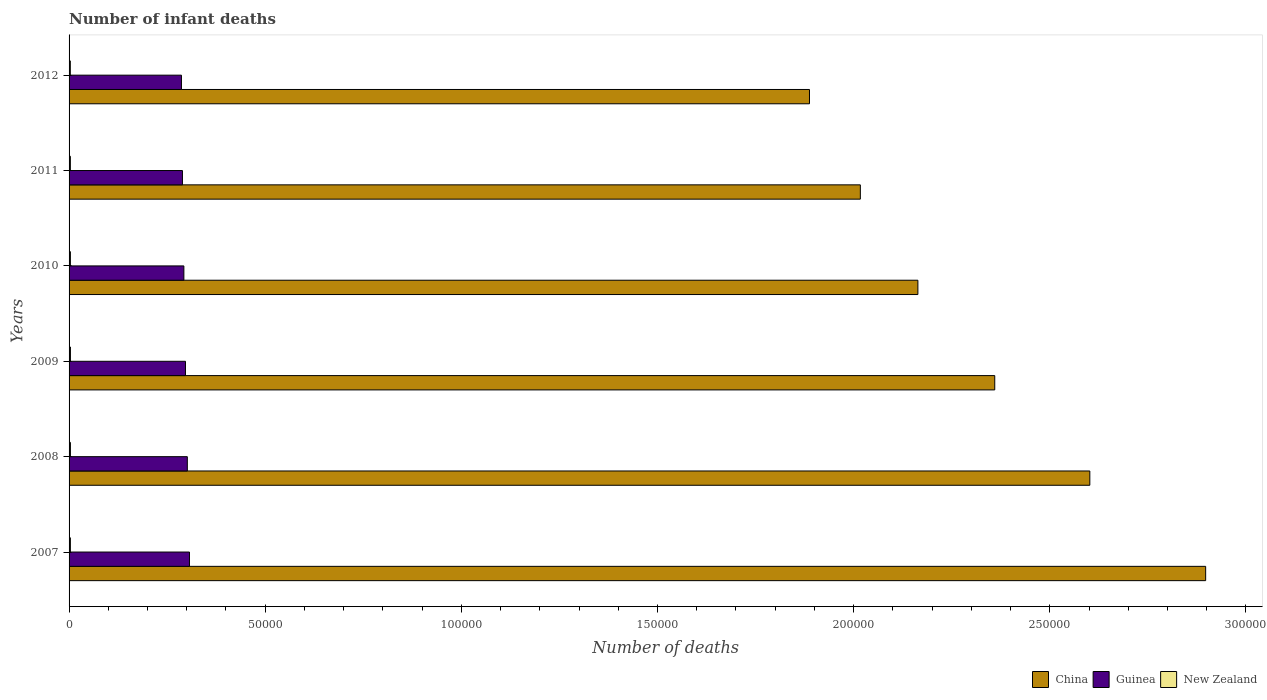How many different coloured bars are there?
Offer a very short reply. 3. Are the number of bars per tick equal to the number of legend labels?
Keep it short and to the point. Yes. How many bars are there on the 4th tick from the top?
Your response must be concise. 3. What is the number of infant deaths in Guinea in 2007?
Offer a terse response. 3.07e+04. Across all years, what is the maximum number of infant deaths in New Zealand?
Make the answer very short. 347. Across all years, what is the minimum number of infant deaths in China?
Make the answer very short. 1.89e+05. In which year was the number of infant deaths in New Zealand maximum?
Offer a very short reply. 2009. What is the total number of infant deaths in Guinea in the graph?
Give a very brief answer. 1.77e+05. What is the difference between the number of infant deaths in New Zealand in 2008 and that in 2009?
Make the answer very short. -1. What is the difference between the number of infant deaths in China in 2010 and the number of infant deaths in Guinea in 2011?
Your response must be concise. 1.87e+05. What is the average number of infant deaths in New Zealand per year?
Give a very brief answer. 337. In the year 2012, what is the difference between the number of infant deaths in China and number of infant deaths in New Zealand?
Keep it short and to the point. 1.88e+05. In how many years, is the number of infant deaths in New Zealand greater than 160000 ?
Make the answer very short. 0. What is the ratio of the number of infant deaths in Guinea in 2007 to that in 2012?
Provide a succinct answer. 1.07. Is the difference between the number of infant deaths in China in 2011 and 2012 greater than the difference between the number of infant deaths in New Zealand in 2011 and 2012?
Offer a very short reply. Yes. What is the difference between the highest and the second highest number of infant deaths in China?
Offer a terse response. 2.95e+04. What is the difference between the highest and the lowest number of infant deaths in New Zealand?
Provide a succinct answer. 28. In how many years, is the number of infant deaths in China greater than the average number of infant deaths in China taken over all years?
Provide a succinct answer. 3. Is the sum of the number of infant deaths in New Zealand in 2009 and 2011 greater than the maximum number of infant deaths in Guinea across all years?
Ensure brevity in your answer.  No. What does the 2nd bar from the top in 2008 represents?
Provide a succinct answer. Guinea. What does the 2nd bar from the bottom in 2010 represents?
Your response must be concise. Guinea. Is it the case that in every year, the sum of the number of infant deaths in Guinea and number of infant deaths in China is greater than the number of infant deaths in New Zealand?
Provide a succinct answer. Yes. Are all the bars in the graph horizontal?
Make the answer very short. Yes. Are the values on the major ticks of X-axis written in scientific E-notation?
Give a very brief answer. No. How many legend labels are there?
Your response must be concise. 3. What is the title of the graph?
Offer a terse response. Number of infant deaths. Does "Ukraine" appear as one of the legend labels in the graph?
Your response must be concise. No. What is the label or title of the X-axis?
Ensure brevity in your answer.  Number of deaths. What is the label or title of the Y-axis?
Offer a terse response. Years. What is the Number of deaths in China in 2007?
Your answer should be very brief. 2.90e+05. What is the Number of deaths in Guinea in 2007?
Your answer should be compact. 3.07e+04. What is the Number of deaths in New Zealand in 2007?
Your response must be concise. 335. What is the Number of deaths of China in 2008?
Your answer should be compact. 2.60e+05. What is the Number of deaths of Guinea in 2008?
Give a very brief answer. 3.01e+04. What is the Number of deaths of New Zealand in 2008?
Provide a short and direct response. 346. What is the Number of deaths in China in 2009?
Offer a terse response. 2.36e+05. What is the Number of deaths of Guinea in 2009?
Offer a very short reply. 2.97e+04. What is the Number of deaths of New Zealand in 2009?
Your response must be concise. 347. What is the Number of deaths of China in 2010?
Provide a succinct answer. 2.16e+05. What is the Number of deaths in Guinea in 2010?
Provide a succinct answer. 2.93e+04. What is the Number of deaths of New Zealand in 2010?
Provide a succinct answer. 342. What is the Number of deaths of China in 2011?
Make the answer very short. 2.02e+05. What is the Number of deaths of Guinea in 2011?
Provide a short and direct response. 2.89e+04. What is the Number of deaths of New Zealand in 2011?
Provide a short and direct response. 333. What is the Number of deaths in China in 2012?
Ensure brevity in your answer.  1.89e+05. What is the Number of deaths in Guinea in 2012?
Your answer should be compact. 2.86e+04. What is the Number of deaths of New Zealand in 2012?
Your answer should be very brief. 319. Across all years, what is the maximum Number of deaths of China?
Make the answer very short. 2.90e+05. Across all years, what is the maximum Number of deaths of Guinea?
Provide a succinct answer. 3.07e+04. Across all years, what is the maximum Number of deaths in New Zealand?
Offer a terse response. 347. Across all years, what is the minimum Number of deaths in China?
Offer a very short reply. 1.89e+05. Across all years, what is the minimum Number of deaths of Guinea?
Provide a succinct answer. 2.86e+04. Across all years, what is the minimum Number of deaths in New Zealand?
Make the answer very short. 319. What is the total Number of deaths of China in the graph?
Your response must be concise. 1.39e+06. What is the total Number of deaths in Guinea in the graph?
Make the answer very short. 1.77e+05. What is the total Number of deaths of New Zealand in the graph?
Keep it short and to the point. 2022. What is the difference between the Number of deaths of China in 2007 and that in 2008?
Give a very brief answer. 2.95e+04. What is the difference between the Number of deaths in Guinea in 2007 and that in 2008?
Your response must be concise. 553. What is the difference between the Number of deaths of New Zealand in 2007 and that in 2008?
Your answer should be very brief. -11. What is the difference between the Number of deaths in China in 2007 and that in 2009?
Your answer should be compact. 5.38e+04. What is the difference between the Number of deaths in Guinea in 2007 and that in 2009?
Ensure brevity in your answer.  1023. What is the difference between the Number of deaths in New Zealand in 2007 and that in 2009?
Offer a terse response. -12. What is the difference between the Number of deaths of China in 2007 and that in 2010?
Give a very brief answer. 7.34e+04. What is the difference between the Number of deaths of Guinea in 2007 and that in 2010?
Your answer should be very brief. 1432. What is the difference between the Number of deaths in China in 2007 and that in 2011?
Offer a terse response. 8.80e+04. What is the difference between the Number of deaths of Guinea in 2007 and that in 2011?
Offer a terse response. 1796. What is the difference between the Number of deaths in New Zealand in 2007 and that in 2011?
Keep it short and to the point. 2. What is the difference between the Number of deaths in China in 2007 and that in 2012?
Offer a very short reply. 1.01e+05. What is the difference between the Number of deaths of Guinea in 2007 and that in 2012?
Offer a very short reply. 2049. What is the difference between the Number of deaths of New Zealand in 2007 and that in 2012?
Provide a short and direct response. 16. What is the difference between the Number of deaths of China in 2008 and that in 2009?
Your answer should be compact. 2.42e+04. What is the difference between the Number of deaths in Guinea in 2008 and that in 2009?
Your answer should be very brief. 470. What is the difference between the Number of deaths in New Zealand in 2008 and that in 2009?
Keep it short and to the point. -1. What is the difference between the Number of deaths in China in 2008 and that in 2010?
Offer a very short reply. 4.38e+04. What is the difference between the Number of deaths of Guinea in 2008 and that in 2010?
Give a very brief answer. 879. What is the difference between the Number of deaths in New Zealand in 2008 and that in 2010?
Your answer should be compact. 4. What is the difference between the Number of deaths in China in 2008 and that in 2011?
Provide a succinct answer. 5.85e+04. What is the difference between the Number of deaths in Guinea in 2008 and that in 2011?
Keep it short and to the point. 1243. What is the difference between the Number of deaths of China in 2008 and that in 2012?
Provide a succinct answer. 7.15e+04. What is the difference between the Number of deaths of Guinea in 2008 and that in 2012?
Offer a terse response. 1496. What is the difference between the Number of deaths in New Zealand in 2008 and that in 2012?
Offer a very short reply. 27. What is the difference between the Number of deaths of China in 2009 and that in 2010?
Provide a short and direct response. 1.96e+04. What is the difference between the Number of deaths of Guinea in 2009 and that in 2010?
Give a very brief answer. 409. What is the difference between the Number of deaths in China in 2009 and that in 2011?
Your answer should be compact. 3.43e+04. What is the difference between the Number of deaths in Guinea in 2009 and that in 2011?
Provide a succinct answer. 773. What is the difference between the Number of deaths in New Zealand in 2009 and that in 2011?
Give a very brief answer. 14. What is the difference between the Number of deaths of China in 2009 and that in 2012?
Keep it short and to the point. 4.72e+04. What is the difference between the Number of deaths of Guinea in 2009 and that in 2012?
Make the answer very short. 1026. What is the difference between the Number of deaths in New Zealand in 2009 and that in 2012?
Ensure brevity in your answer.  28. What is the difference between the Number of deaths in China in 2010 and that in 2011?
Provide a succinct answer. 1.47e+04. What is the difference between the Number of deaths in Guinea in 2010 and that in 2011?
Offer a very short reply. 364. What is the difference between the Number of deaths of China in 2010 and that in 2012?
Your answer should be compact. 2.76e+04. What is the difference between the Number of deaths of Guinea in 2010 and that in 2012?
Make the answer very short. 617. What is the difference between the Number of deaths in New Zealand in 2010 and that in 2012?
Keep it short and to the point. 23. What is the difference between the Number of deaths in China in 2011 and that in 2012?
Your response must be concise. 1.30e+04. What is the difference between the Number of deaths in Guinea in 2011 and that in 2012?
Keep it short and to the point. 253. What is the difference between the Number of deaths in China in 2007 and the Number of deaths in Guinea in 2008?
Ensure brevity in your answer.  2.60e+05. What is the difference between the Number of deaths of China in 2007 and the Number of deaths of New Zealand in 2008?
Ensure brevity in your answer.  2.89e+05. What is the difference between the Number of deaths of Guinea in 2007 and the Number of deaths of New Zealand in 2008?
Your answer should be compact. 3.04e+04. What is the difference between the Number of deaths of China in 2007 and the Number of deaths of Guinea in 2009?
Give a very brief answer. 2.60e+05. What is the difference between the Number of deaths of China in 2007 and the Number of deaths of New Zealand in 2009?
Provide a succinct answer. 2.89e+05. What is the difference between the Number of deaths in Guinea in 2007 and the Number of deaths in New Zealand in 2009?
Make the answer very short. 3.04e+04. What is the difference between the Number of deaths of China in 2007 and the Number of deaths of Guinea in 2010?
Your answer should be compact. 2.60e+05. What is the difference between the Number of deaths in China in 2007 and the Number of deaths in New Zealand in 2010?
Provide a succinct answer. 2.89e+05. What is the difference between the Number of deaths in Guinea in 2007 and the Number of deaths in New Zealand in 2010?
Offer a very short reply. 3.04e+04. What is the difference between the Number of deaths in China in 2007 and the Number of deaths in Guinea in 2011?
Offer a very short reply. 2.61e+05. What is the difference between the Number of deaths in China in 2007 and the Number of deaths in New Zealand in 2011?
Offer a terse response. 2.89e+05. What is the difference between the Number of deaths in Guinea in 2007 and the Number of deaths in New Zealand in 2011?
Ensure brevity in your answer.  3.04e+04. What is the difference between the Number of deaths in China in 2007 and the Number of deaths in Guinea in 2012?
Ensure brevity in your answer.  2.61e+05. What is the difference between the Number of deaths of China in 2007 and the Number of deaths of New Zealand in 2012?
Your answer should be compact. 2.89e+05. What is the difference between the Number of deaths in Guinea in 2007 and the Number of deaths in New Zealand in 2012?
Give a very brief answer. 3.04e+04. What is the difference between the Number of deaths in China in 2008 and the Number of deaths in Guinea in 2009?
Offer a very short reply. 2.31e+05. What is the difference between the Number of deaths of China in 2008 and the Number of deaths of New Zealand in 2009?
Make the answer very short. 2.60e+05. What is the difference between the Number of deaths of Guinea in 2008 and the Number of deaths of New Zealand in 2009?
Keep it short and to the point. 2.98e+04. What is the difference between the Number of deaths of China in 2008 and the Number of deaths of Guinea in 2010?
Your response must be concise. 2.31e+05. What is the difference between the Number of deaths in China in 2008 and the Number of deaths in New Zealand in 2010?
Your answer should be very brief. 2.60e+05. What is the difference between the Number of deaths of Guinea in 2008 and the Number of deaths of New Zealand in 2010?
Offer a very short reply. 2.98e+04. What is the difference between the Number of deaths in China in 2008 and the Number of deaths in Guinea in 2011?
Provide a succinct answer. 2.31e+05. What is the difference between the Number of deaths of China in 2008 and the Number of deaths of New Zealand in 2011?
Your answer should be compact. 2.60e+05. What is the difference between the Number of deaths in Guinea in 2008 and the Number of deaths in New Zealand in 2011?
Make the answer very short. 2.98e+04. What is the difference between the Number of deaths of China in 2008 and the Number of deaths of Guinea in 2012?
Your answer should be compact. 2.32e+05. What is the difference between the Number of deaths of China in 2008 and the Number of deaths of New Zealand in 2012?
Your answer should be compact. 2.60e+05. What is the difference between the Number of deaths of Guinea in 2008 and the Number of deaths of New Zealand in 2012?
Your response must be concise. 2.98e+04. What is the difference between the Number of deaths of China in 2009 and the Number of deaths of Guinea in 2010?
Your answer should be compact. 2.07e+05. What is the difference between the Number of deaths of China in 2009 and the Number of deaths of New Zealand in 2010?
Your response must be concise. 2.36e+05. What is the difference between the Number of deaths in Guinea in 2009 and the Number of deaths in New Zealand in 2010?
Give a very brief answer. 2.93e+04. What is the difference between the Number of deaths in China in 2009 and the Number of deaths in Guinea in 2011?
Offer a very short reply. 2.07e+05. What is the difference between the Number of deaths in China in 2009 and the Number of deaths in New Zealand in 2011?
Make the answer very short. 2.36e+05. What is the difference between the Number of deaths in Guinea in 2009 and the Number of deaths in New Zealand in 2011?
Your answer should be compact. 2.93e+04. What is the difference between the Number of deaths of China in 2009 and the Number of deaths of Guinea in 2012?
Provide a short and direct response. 2.07e+05. What is the difference between the Number of deaths in China in 2009 and the Number of deaths in New Zealand in 2012?
Provide a succinct answer. 2.36e+05. What is the difference between the Number of deaths in Guinea in 2009 and the Number of deaths in New Zealand in 2012?
Provide a short and direct response. 2.94e+04. What is the difference between the Number of deaths of China in 2010 and the Number of deaths of Guinea in 2011?
Ensure brevity in your answer.  1.87e+05. What is the difference between the Number of deaths in China in 2010 and the Number of deaths in New Zealand in 2011?
Offer a terse response. 2.16e+05. What is the difference between the Number of deaths of Guinea in 2010 and the Number of deaths of New Zealand in 2011?
Your answer should be compact. 2.89e+04. What is the difference between the Number of deaths in China in 2010 and the Number of deaths in Guinea in 2012?
Provide a short and direct response. 1.88e+05. What is the difference between the Number of deaths of China in 2010 and the Number of deaths of New Zealand in 2012?
Keep it short and to the point. 2.16e+05. What is the difference between the Number of deaths in Guinea in 2010 and the Number of deaths in New Zealand in 2012?
Your answer should be compact. 2.89e+04. What is the difference between the Number of deaths of China in 2011 and the Number of deaths of Guinea in 2012?
Your answer should be compact. 1.73e+05. What is the difference between the Number of deaths of China in 2011 and the Number of deaths of New Zealand in 2012?
Make the answer very short. 2.01e+05. What is the difference between the Number of deaths in Guinea in 2011 and the Number of deaths in New Zealand in 2012?
Keep it short and to the point. 2.86e+04. What is the average Number of deaths of China per year?
Offer a very short reply. 2.32e+05. What is the average Number of deaths in Guinea per year?
Offer a very short reply. 2.96e+04. What is the average Number of deaths in New Zealand per year?
Keep it short and to the point. 337. In the year 2007, what is the difference between the Number of deaths in China and Number of deaths in Guinea?
Provide a succinct answer. 2.59e+05. In the year 2007, what is the difference between the Number of deaths in China and Number of deaths in New Zealand?
Make the answer very short. 2.89e+05. In the year 2007, what is the difference between the Number of deaths in Guinea and Number of deaths in New Zealand?
Offer a very short reply. 3.04e+04. In the year 2008, what is the difference between the Number of deaths in China and Number of deaths in Guinea?
Give a very brief answer. 2.30e+05. In the year 2008, what is the difference between the Number of deaths in China and Number of deaths in New Zealand?
Ensure brevity in your answer.  2.60e+05. In the year 2008, what is the difference between the Number of deaths of Guinea and Number of deaths of New Zealand?
Give a very brief answer. 2.98e+04. In the year 2009, what is the difference between the Number of deaths in China and Number of deaths in Guinea?
Your answer should be compact. 2.06e+05. In the year 2009, what is the difference between the Number of deaths of China and Number of deaths of New Zealand?
Make the answer very short. 2.36e+05. In the year 2009, what is the difference between the Number of deaths of Guinea and Number of deaths of New Zealand?
Ensure brevity in your answer.  2.93e+04. In the year 2010, what is the difference between the Number of deaths in China and Number of deaths in Guinea?
Give a very brief answer. 1.87e+05. In the year 2010, what is the difference between the Number of deaths of China and Number of deaths of New Zealand?
Keep it short and to the point. 2.16e+05. In the year 2010, what is the difference between the Number of deaths in Guinea and Number of deaths in New Zealand?
Provide a short and direct response. 2.89e+04. In the year 2011, what is the difference between the Number of deaths in China and Number of deaths in Guinea?
Keep it short and to the point. 1.73e+05. In the year 2011, what is the difference between the Number of deaths of China and Number of deaths of New Zealand?
Your answer should be very brief. 2.01e+05. In the year 2011, what is the difference between the Number of deaths in Guinea and Number of deaths in New Zealand?
Provide a succinct answer. 2.86e+04. In the year 2012, what is the difference between the Number of deaths in China and Number of deaths in Guinea?
Offer a very short reply. 1.60e+05. In the year 2012, what is the difference between the Number of deaths of China and Number of deaths of New Zealand?
Ensure brevity in your answer.  1.88e+05. In the year 2012, what is the difference between the Number of deaths in Guinea and Number of deaths in New Zealand?
Provide a short and direct response. 2.83e+04. What is the ratio of the Number of deaths of China in 2007 to that in 2008?
Give a very brief answer. 1.11. What is the ratio of the Number of deaths of Guinea in 2007 to that in 2008?
Offer a very short reply. 1.02. What is the ratio of the Number of deaths in New Zealand in 2007 to that in 2008?
Ensure brevity in your answer.  0.97. What is the ratio of the Number of deaths of China in 2007 to that in 2009?
Ensure brevity in your answer.  1.23. What is the ratio of the Number of deaths in Guinea in 2007 to that in 2009?
Provide a succinct answer. 1.03. What is the ratio of the Number of deaths in New Zealand in 2007 to that in 2009?
Offer a very short reply. 0.97. What is the ratio of the Number of deaths of China in 2007 to that in 2010?
Give a very brief answer. 1.34. What is the ratio of the Number of deaths in Guinea in 2007 to that in 2010?
Give a very brief answer. 1.05. What is the ratio of the Number of deaths in New Zealand in 2007 to that in 2010?
Offer a very short reply. 0.98. What is the ratio of the Number of deaths of China in 2007 to that in 2011?
Offer a very short reply. 1.44. What is the ratio of the Number of deaths of Guinea in 2007 to that in 2011?
Make the answer very short. 1.06. What is the ratio of the Number of deaths of China in 2007 to that in 2012?
Give a very brief answer. 1.54. What is the ratio of the Number of deaths of Guinea in 2007 to that in 2012?
Provide a short and direct response. 1.07. What is the ratio of the Number of deaths in New Zealand in 2007 to that in 2012?
Make the answer very short. 1.05. What is the ratio of the Number of deaths in China in 2008 to that in 2009?
Offer a very short reply. 1.1. What is the ratio of the Number of deaths in Guinea in 2008 to that in 2009?
Your answer should be very brief. 1.02. What is the ratio of the Number of deaths in China in 2008 to that in 2010?
Your answer should be compact. 1.2. What is the ratio of the Number of deaths in Guinea in 2008 to that in 2010?
Offer a very short reply. 1.03. What is the ratio of the Number of deaths of New Zealand in 2008 to that in 2010?
Make the answer very short. 1.01. What is the ratio of the Number of deaths of China in 2008 to that in 2011?
Offer a terse response. 1.29. What is the ratio of the Number of deaths of Guinea in 2008 to that in 2011?
Give a very brief answer. 1.04. What is the ratio of the Number of deaths of New Zealand in 2008 to that in 2011?
Provide a short and direct response. 1.04. What is the ratio of the Number of deaths in China in 2008 to that in 2012?
Ensure brevity in your answer.  1.38. What is the ratio of the Number of deaths in Guinea in 2008 to that in 2012?
Provide a short and direct response. 1.05. What is the ratio of the Number of deaths of New Zealand in 2008 to that in 2012?
Provide a succinct answer. 1.08. What is the ratio of the Number of deaths in China in 2009 to that in 2010?
Your answer should be compact. 1.09. What is the ratio of the Number of deaths of Guinea in 2009 to that in 2010?
Provide a short and direct response. 1.01. What is the ratio of the Number of deaths in New Zealand in 2009 to that in 2010?
Ensure brevity in your answer.  1.01. What is the ratio of the Number of deaths of China in 2009 to that in 2011?
Your answer should be very brief. 1.17. What is the ratio of the Number of deaths of Guinea in 2009 to that in 2011?
Your response must be concise. 1.03. What is the ratio of the Number of deaths of New Zealand in 2009 to that in 2011?
Your answer should be very brief. 1.04. What is the ratio of the Number of deaths of China in 2009 to that in 2012?
Offer a terse response. 1.25. What is the ratio of the Number of deaths of Guinea in 2009 to that in 2012?
Your answer should be compact. 1.04. What is the ratio of the Number of deaths of New Zealand in 2009 to that in 2012?
Give a very brief answer. 1.09. What is the ratio of the Number of deaths in China in 2010 to that in 2011?
Ensure brevity in your answer.  1.07. What is the ratio of the Number of deaths of Guinea in 2010 to that in 2011?
Your answer should be compact. 1.01. What is the ratio of the Number of deaths in New Zealand in 2010 to that in 2011?
Make the answer very short. 1.03. What is the ratio of the Number of deaths in China in 2010 to that in 2012?
Your response must be concise. 1.15. What is the ratio of the Number of deaths in Guinea in 2010 to that in 2012?
Make the answer very short. 1.02. What is the ratio of the Number of deaths of New Zealand in 2010 to that in 2012?
Keep it short and to the point. 1.07. What is the ratio of the Number of deaths in China in 2011 to that in 2012?
Offer a very short reply. 1.07. What is the ratio of the Number of deaths in Guinea in 2011 to that in 2012?
Offer a terse response. 1.01. What is the ratio of the Number of deaths of New Zealand in 2011 to that in 2012?
Ensure brevity in your answer.  1.04. What is the difference between the highest and the second highest Number of deaths in China?
Keep it short and to the point. 2.95e+04. What is the difference between the highest and the second highest Number of deaths of Guinea?
Provide a short and direct response. 553. What is the difference between the highest and the lowest Number of deaths in China?
Your response must be concise. 1.01e+05. What is the difference between the highest and the lowest Number of deaths of Guinea?
Your answer should be compact. 2049. What is the difference between the highest and the lowest Number of deaths of New Zealand?
Ensure brevity in your answer.  28. 